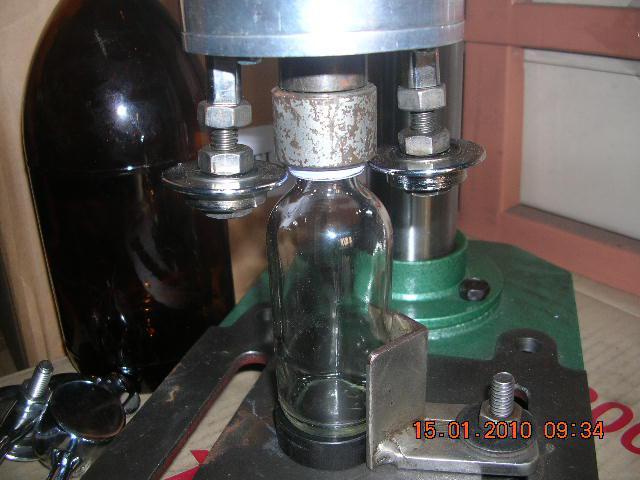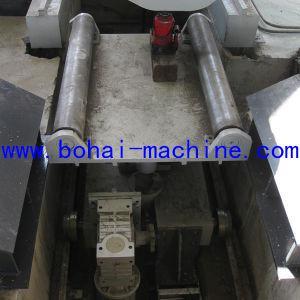The first image is the image on the left, the second image is the image on the right. Examine the images to the left and right. Is the description "The left and right image contains the same amount of round metal barrels." accurate? Answer yes or no. No. 